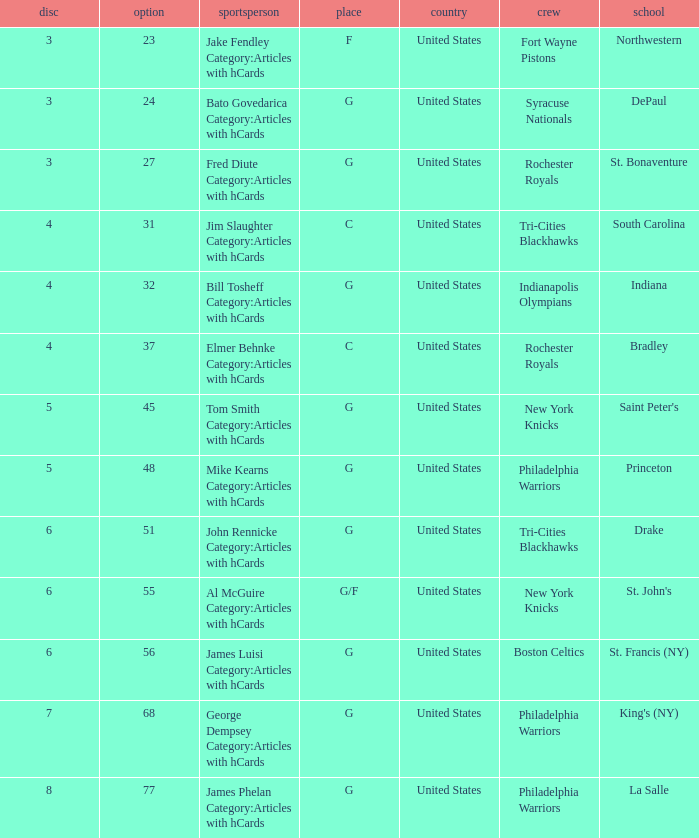What is the sum total of picks for drake players from the tri-cities blackhawks? 51.0. 